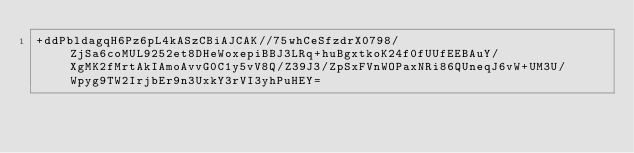Convert code to text. <code><loc_0><loc_0><loc_500><loc_500><_SML_>+ddPbldagqH6Pz6pL4kASzCBiAJCAK//75whCeSfzdrX0798/ZjSa6coMUL9252et8DHeWoxepiBBJ3LRq+huBgxtkoK24f0fUUfEEBAuY/XgMK2fMrtAkIAmoAvvG0C1y5vV8Q/Z39J3/ZpSxFVnWOPaxNRi86QUneqJ6vW+UM3U/Wpyg9TW2IrjbEr9n3UxkY3rVI3yhPuHEY=</code> 